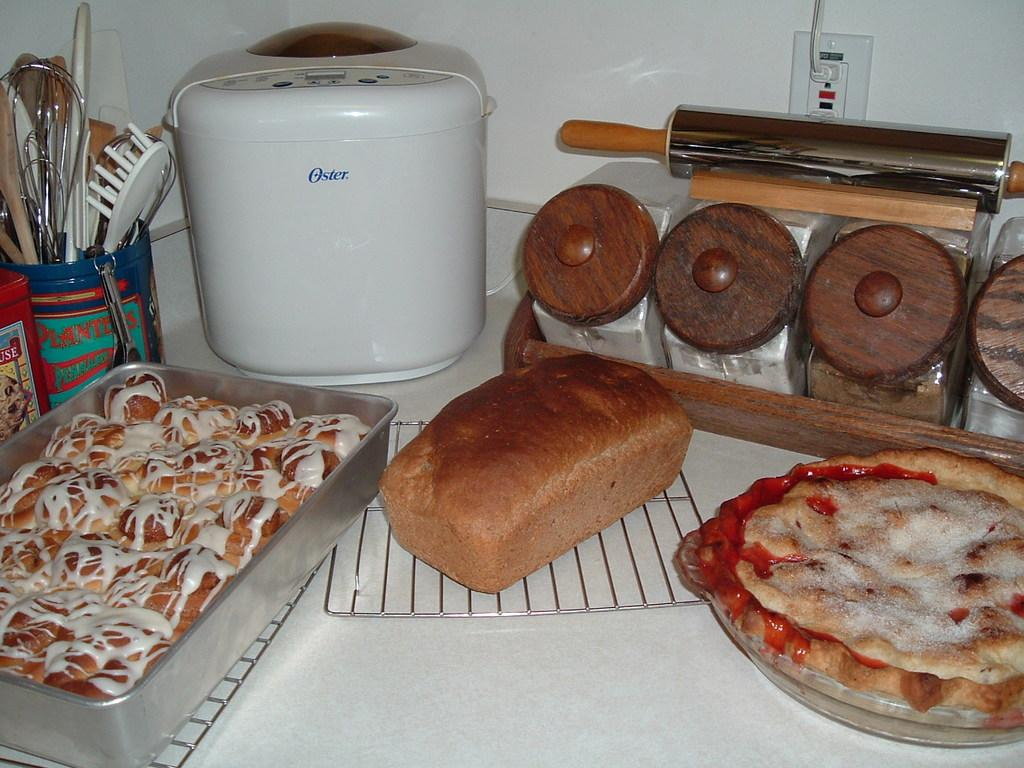<image>
Offer a succinct explanation of the picture presented. Three baked goods sit on a counter along with an Oster appliance. 